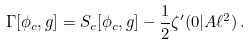Convert formula to latex. <formula><loc_0><loc_0><loc_500><loc_500>\Gamma [ \phi _ { c } , g ] = S _ { c } [ \phi _ { c } , g ] - \frac { 1 } { 2 } \zeta ^ { \prime } ( 0 | A \ell ^ { 2 } ) \, .</formula> 